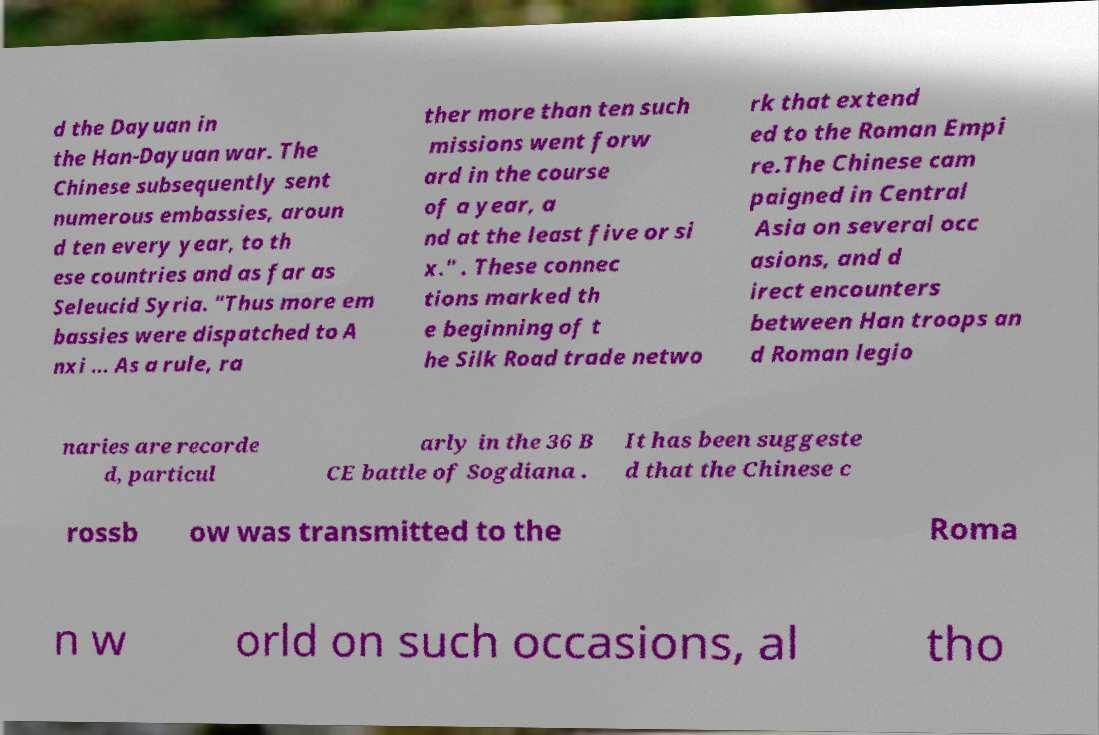There's text embedded in this image that I need extracted. Can you transcribe it verbatim? d the Dayuan in the Han-Dayuan war. The Chinese subsequently sent numerous embassies, aroun d ten every year, to th ese countries and as far as Seleucid Syria. "Thus more em bassies were dispatched to A nxi ... As a rule, ra ther more than ten such missions went forw ard in the course of a year, a nd at the least five or si x." . These connec tions marked th e beginning of t he Silk Road trade netwo rk that extend ed to the Roman Empi re.The Chinese cam paigned in Central Asia on several occ asions, and d irect encounters between Han troops an d Roman legio naries are recorde d, particul arly in the 36 B CE battle of Sogdiana . It has been suggeste d that the Chinese c rossb ow was transmitted to the Roma n w orld on such occasions, al tho 